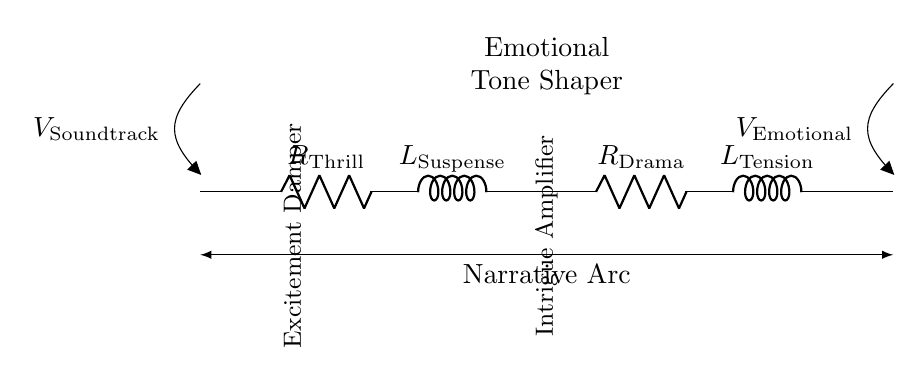What is the value of the resistor labeled "R Thrill"? The circuit diagram labels this resistor as "R Thrill," but it does not indicate a specific numerical value. Therefore, the value is unknown from visual information alone.
Answer: Unknown What component amplifies intrigue in the circuit? The circuit includes an inductor labeled "L Suspense," which is positioned to amplify intrigue due to its role in RL filters.
Answer: L Suspense What is the significance of R Drama and L Tension in this circuit? R Drama and L Tension work together as a part of the audio equalizer circuit to shape the emotional tone, with R Drama as a resistor impeding current flow and L Tension providing inductive reactance.
Answer: Emotional tone shaper How many components are there in total? The circuit features four main components: two resistors (R Thrill and R Drama) and two inductors (L Suspense and L Tension), yielding a total of four components.
Answer: Four What function does the "Excitement Damper" serve? The label "Excitement Damper" refers to R Thrill, which is likely designed to decrease the flow of electrical current, thus dampening excessive excitement in the signal to create a more balanced output.
Answer: Decrease current flow Which voltage represents the input signal to the circuit? The voltage "V Soundtrack" represents the input signal to the circuit, as indicated at the beginning of the circuit diagram.
Answer: V Soundtrack How does this circuit express emotional tone through its components? The circuit uses the combination of resistors and inductors to create RL filters that selectively shape the frequency response of the signal, thereby enhancing or dampening certain emotional qualities during audio playback.
Answer: Shape frequency response 